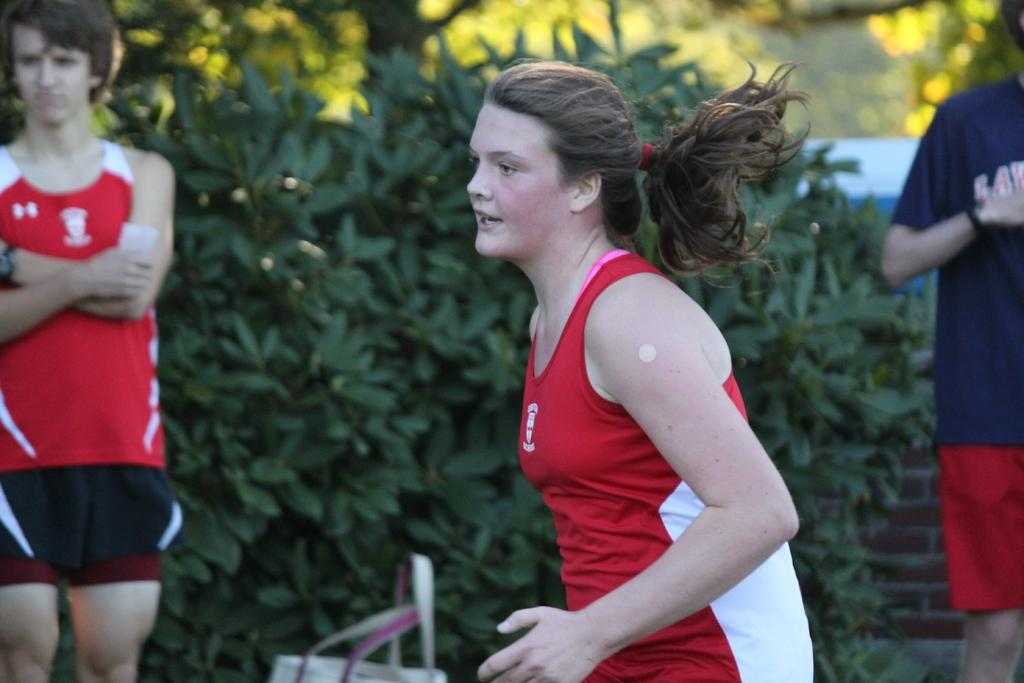What is the main subject of the image? There is a woman standing in the image. Are there any other people in the image? Yes, there are people standing at the back in the image. What can be seen in the background of the image? There are plants visible in the background of the image. What type of corn can be seen growing on the woman's head in the image? There is no corn present in the image, nor is there any corn growing on the woman's head. 